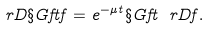<formula> <loc_0><loc_0><loc_500><loc_500>\ r D \S G f { t } f = e ^ { - \mu t } \S G f { t } \ r D f .</formula> 